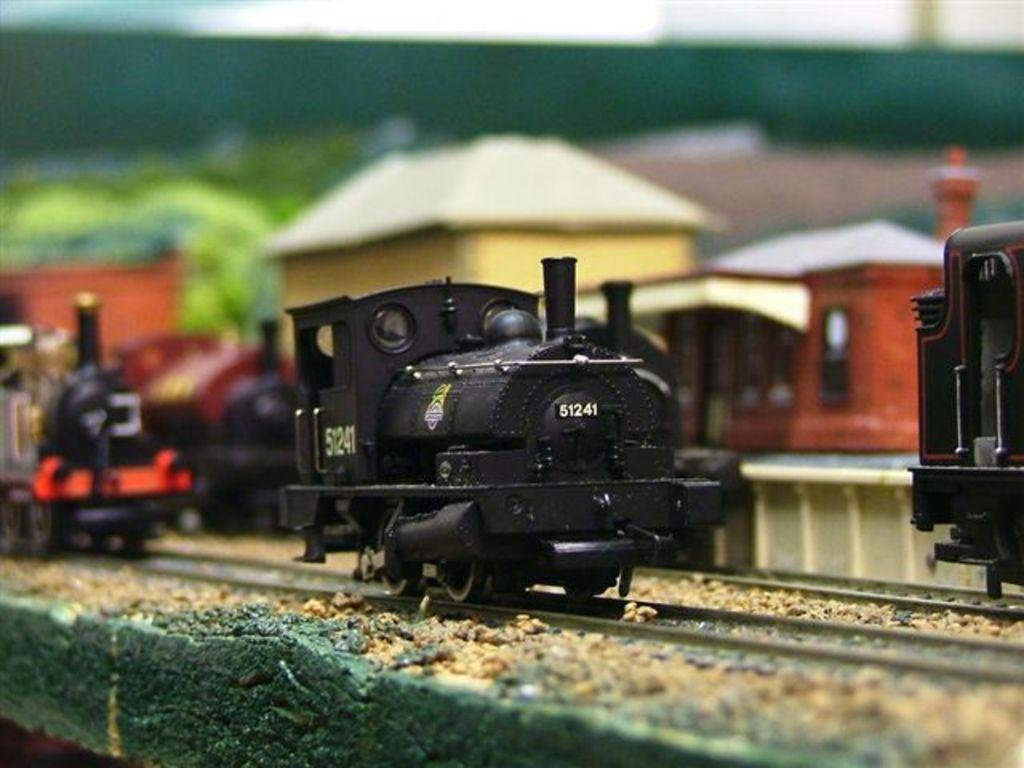What type of toys can be seen in the image? There are toy trains in the image. Are there any other types of toys besides the trains? Yes, there are other toys in the image. Can you describe the background of the image? The background of the image is blurry (subjective observation). How many slaves are visible in the image? There are no slaves present in the image. What type of texture can be seen on the toy trains? The provided facts do not mention the texture of the toy trains, so it cannot be determined from the image. 